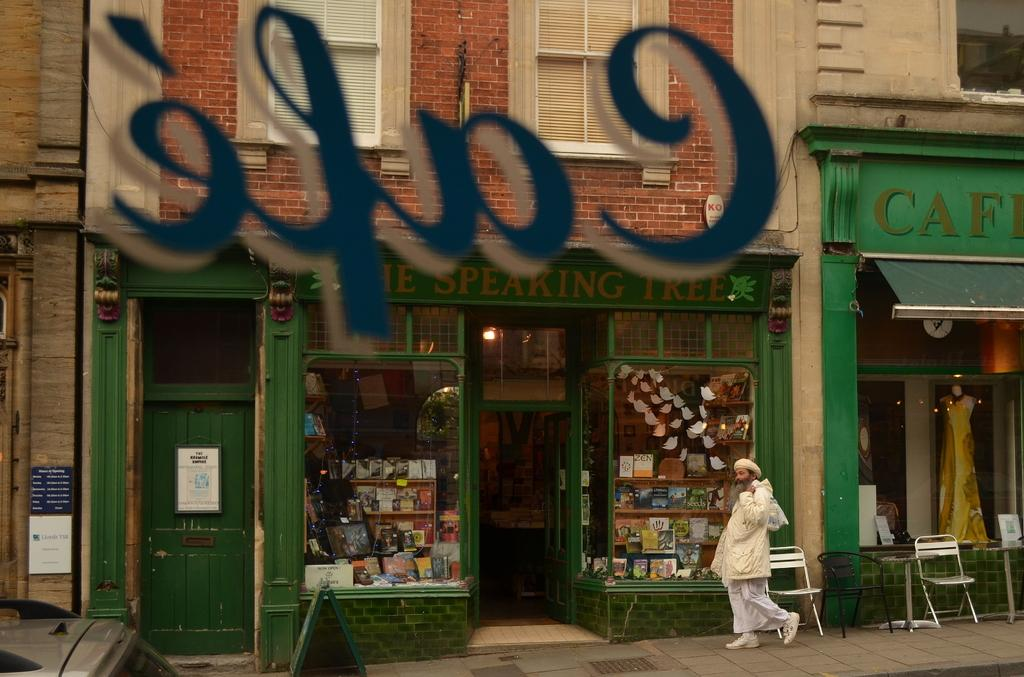<image>
Summarize the visual content of the image. Person walking in front of a green store named Speaking Tree. 